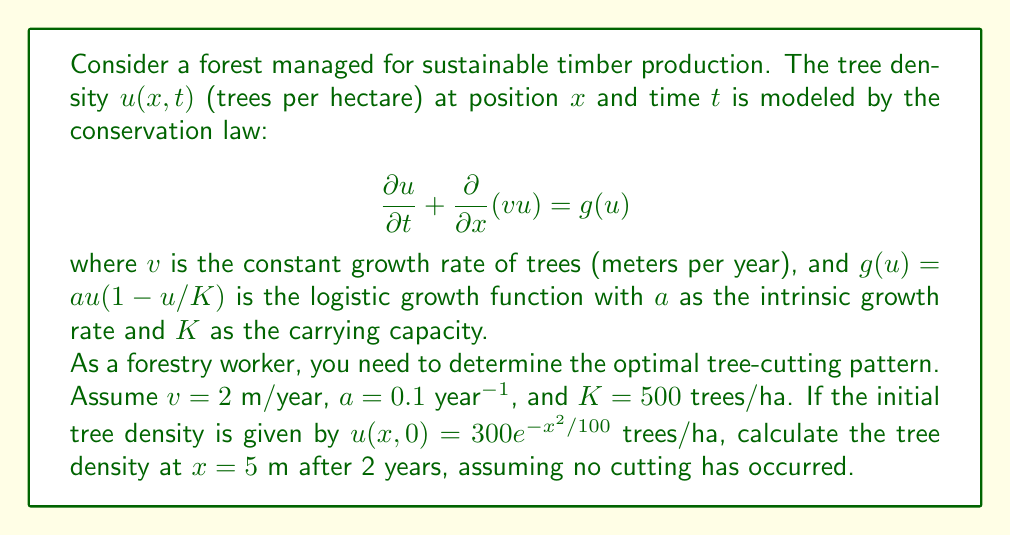Can you answer this question? To solve this problem, we need to use the method of characteristics for the given partial differential equation (PDE). Here's a step-by-step approach:

1) First, we rewrite the PDE in its characteristic form:

   $$\frac{du}{dt} = g(u) = au(1-u/K)$$

   This is because along the characteristic curves, $dx/dt = v$.

2) The characteristic curves are given by $x = x_0 + vt$, where $x_0$ is the initial position.

3) We need to solve the ordinary differential equation (ODE):

   $$\frac{du}{dt} = 0.1u(1-u/500)$$

4) This is a separable ODE. We can solve it as follows:

   $$\int \frac{du}{u(1-u/500)} = 0.1 \int dt$$

5) Solving this integral (using partial fractions), we get:

   $$\ln|\frac{u}{500-u}| = 0.1t + C$$

6) Using the initial condition $u(x,0) = 300e^{-x^2/100}$, we can find $C$:

   $$C = \ln|\frac{300e^{-x_0^2/100}}{500-300e^{-x_0^2/100}}|$$

7) Therefore, the solution is:

   $$u(x,t) = \frac{500}{1 + (\frac{500}{300e^{-x_0^2/100}} - 1)e^{-0.1t}}$$

8) We need to find $u(5,2)$. The characteristic passing through $(5,2)$ starts at $x_0 = 5 - vt = 5 - 2(2) = 1$.

9) Substituting $x_0 = 1$ and $t = 2$ into our solution:

   $$u(5,2) = \frac{500}{1 + (\frac{500}{300e^{-1^2/100}} - 1)e^{-0.1(2)}}$$

10) Calculating this value gives us the final answer.
Answer: $u(5,2) \approx 296.8$ trees/ha 